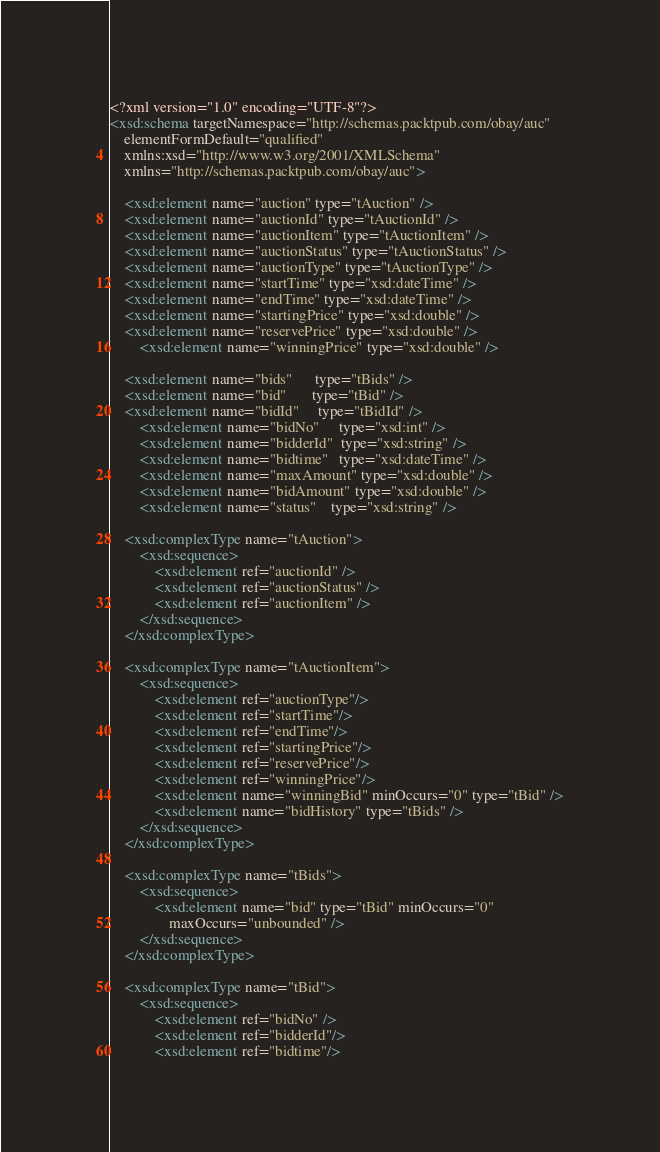<code> <loc_0><loc_0><loc_500><loc_500><_XML_><?xml version="1.0" encoding="UTF-8"?>
<xsd:schema targetNamespace="http://schemas.packtpub.com/obay/auc"
	elementFormDefault="qualified"
	xmlns:xsd="http://www.w3.org/2001/XMLSchema"
	xmlns="http://schemas.packtpub.com/obay/auc">

	<xsd:element name="auction" type="tAuction" />
	<xsd:element name="auctionId" type="tAuctionId" />
	<xsd:element name="auctionItem" type="tAuctionItem" />
	<xsd:element name="auctionStatus" type="tAuctionStatus" />
	<xsd:element name="auctionType" type="tAuctionType" />
	<xsd:element name="startTime" type="xsd:dateTime" />
	<xsd:element name="endTime" type="xsd:dateTime" />
	<xsd:element name="startingPrice" type="xsd:double" />
	<xsd:element name="reservePrice" type="xsd:double" />
        <xsd:element name="winningPrice" type="xsd:double" />
        
	<xsd:element name="bids"      type="tBids" />
	<xsd:element name="bid"       type="tBid" />
	<xsd:element name="bidId"     type="tBidId" /> 
        <xsd:element name="bidNo"     type="xsd:int" />
        <xsd:element name="bidderId"  type="xsd:string" />
        <xsd:element name="bidtime"   type="xsd:dateTime" />
        <xsd:element name="maxAmount" type="xsd:double" />
        <xsd:element name="bidAmount" type="xsd:double" />
        <xsd:element name="status"    type="xsd:string" />

	<xsd:complexType name="tAuction">
		<xsd:sequence>
			<xsd:element ref="auctionId" />
			<xsd:element ref="auctionStatus" />
			<xsd:element ref="auctionItem" />
		</xsd:sequence>
	</xsd:complexType>
	
	<xsd:complexType name="tAuctionItem">
		<xsd:sequence>
			<xsd:element ref="auctionType"/>
			<xsd:element ref="startTime"/>
			<xsd:element ref="endTime"/>
			<xsd:element ref="startingPrice"/>
			<xsd:element ref="reservePrice"/>
			<xsd:element ref="winningPrice"/>
			<xsd:element name="winningBid" minOccurs="0" type="tBid" />
			<xsd:element name="bidHistory" type="tBids" />
		</xsd:sequence>
	</xsd:complexType>

	<xsd:complexType name="tBids">
		<xsd:sequence>
			<xsd:element name="bid" type="tBid" minOccurs="0"
				maxOccurs="unbounded" />
		</xsd:sequence>
	</xsd:complexType>

	<xsd:complexType name="tBid">
		<xsd:sequence>
			<xsd:element ref="bidNo" />
			<xsd:element ref="bidderId"/>
			<xsd:element ref="bidtime"/></code> 